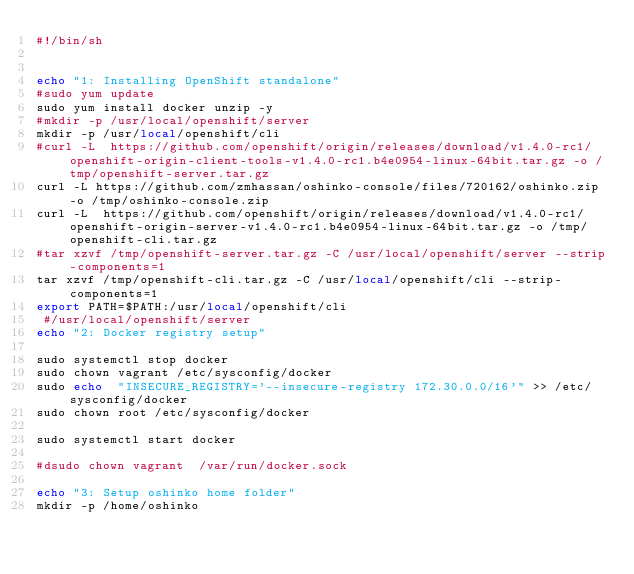<code> <loc_0><loc_0><loc_500><loc_500><_Bash_>#!/bin/sh


echo "1: Installing OpenShift standalone"
#sudo yum update
sudo yum install docker unzip -y
#mkdir -p /usr/local/openshift/server
mkdir -p /usr/local/openshift/cli
#curl -L  https://github.com/openshift/origin/releases/download/v1.4.0-rc1/openshift-origin-client-tools-v1.4.0-rc1.b4e0954-linux-64bit.tar.gz -o /tmp/openshift-server.tar.gz
curl -L https://github.com/zmhassan/oshinko-console/files/720162/oshinko.zip -o /tmp/oshinko-console.zip
curl -L  https://github.com/openshift/origin/releases/download/v1.4.0-rc1/openshift-origin-server-v1.4.0-rc1.b4e0954-linux-64bit.tar.gz -o /tmp/openshift-cli.tar.gz
#tar xzvf /tmp/openshift-server.tar.gz -C /usr/local/openshift/server --strip-components=1
tar xzvf /tmp/openshift-cli.tar.gz -C /usr/local/openshift/cli --strip-components=1
export PATH=$PATH:/usr/local/openshift/cli
 #/usr/local/openshift/server
echo "2: Docker registry setup"

sudo systemctl stop docker
sudo chown vagrant /etc/sysconfig/docker
sudo echo  "INSECURE_REGISTRY='--insecure-registry 172.30.0.0/16'" >> /etc/sysconfig/docker
sudo chown root /etc/sysconfig/docker

sudo systemctl start docker

#dsudo chown vagrant  /var/run/docker.sock

echo "3: Setup oshinko home folder"
mkdir -p /home/oshinko</code> 